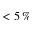<formula> <loc_0><loc_0><loc_500><loc_500>< 5 \, \%</formula> 